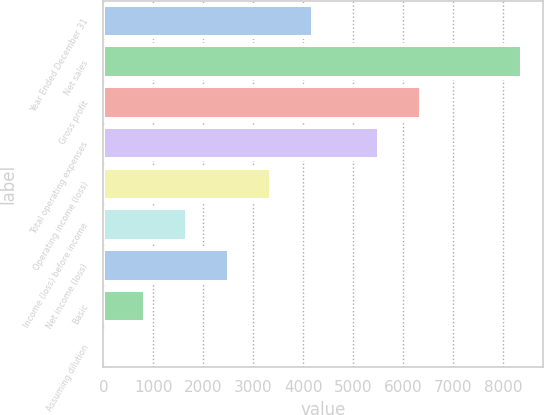Convert chart to OTSL. <chart><loc_0><loc_0><loc_500><loc_500><bar_chart><fcel>Year Ended December 31<fcel>Net sales<fcel>Gross profit<fcel>Total operating expenses<fcel>Operating income (loss)<fcel>Income (loss) before income<fcel>Net income (loss)<fcel>Basic<fcel>Assuming dilution<nl><fcel>4193.14<fcel>8386<fcel>6353.57<fcel>5515<fcel>3354.56<fcel>1677.41<fcel>2515.99<fcel>838.83<fcel>0.25<nl></chart> 